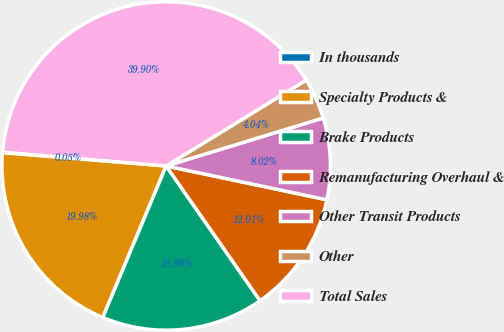Convert chart to OTSL. <chart><loc_0><loc_0><loc_500><loc_500><pie_chart><fcel>In thousands<fcel>Specialty Products &<fcel>Brake Products<fcel>Remanufacturing Overhaul &<fcel>Other Transit Products<fcel>Other<fcel>Total Sales<nl><fcel>0.05%<fcel>19.98%<fcel>15.99%<fcel>12.01%<fcel>8.02%<fcel>4.04%<fcel>39.9%<nl></chart> 